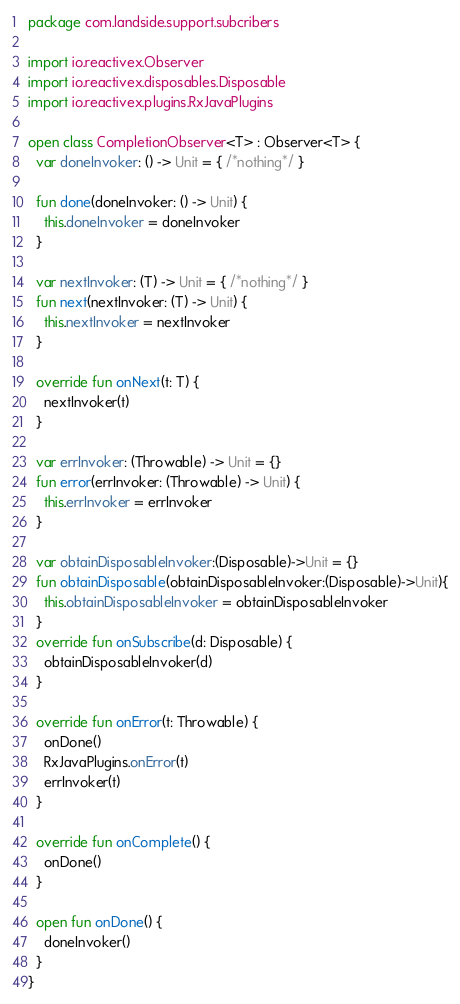<code> <loc_0><loc_0><loc_500><loc_500><_Kotlin_>package com.landside.support.subcribers

import io.reactivex.Observer
import io.reactivex.disposables.Disposable
import io.reactivex.plugins.RxJavaPlugins

open class CompletionObserver<T> : Observer<T> {
  var doneInvoker: () -> Unit = { /*nothing*/ }

  fun done(doneInvoker: () -> Unit) {
    this.doneInvoker = doneInvoker
  }

  var nextInvoker: (T) -> Unit = { /*nothing*/ }
  fun next(nextInvoker: (T) -> Unit) {
    this.nextInvoker = nextInvoker
  }

  override fun onNext(t: T) {
    nextInvoker(t)
  }

  var errInvoker: (Throwable) -> Unit = {}
  fun error(errInvoker: (Throwable) -> Unit) {
    this.errInvoker = errInvoker
  }

  var obtainDisposableInvoker:(Disposable)->Unit = {}
  fun obtainDisposable(obtainDisposableInvoker:(Disposable)->Unit){
    this.obtainDisposableInvoker = obtainDisposableInvoker
  }
  override fun onSubscribe(d: Disposable) {
    obtainDisposableInvoker(d)
  }

  override fun onError(t: Throwable) {
    onDone()
    RxJavaPlugins.onError(t)
    errInvoker(t)
  }

  override fun onComplete() {
    onDone()
  }

  open fun onDone() {
    doneInvoker()
  }
}</code> 